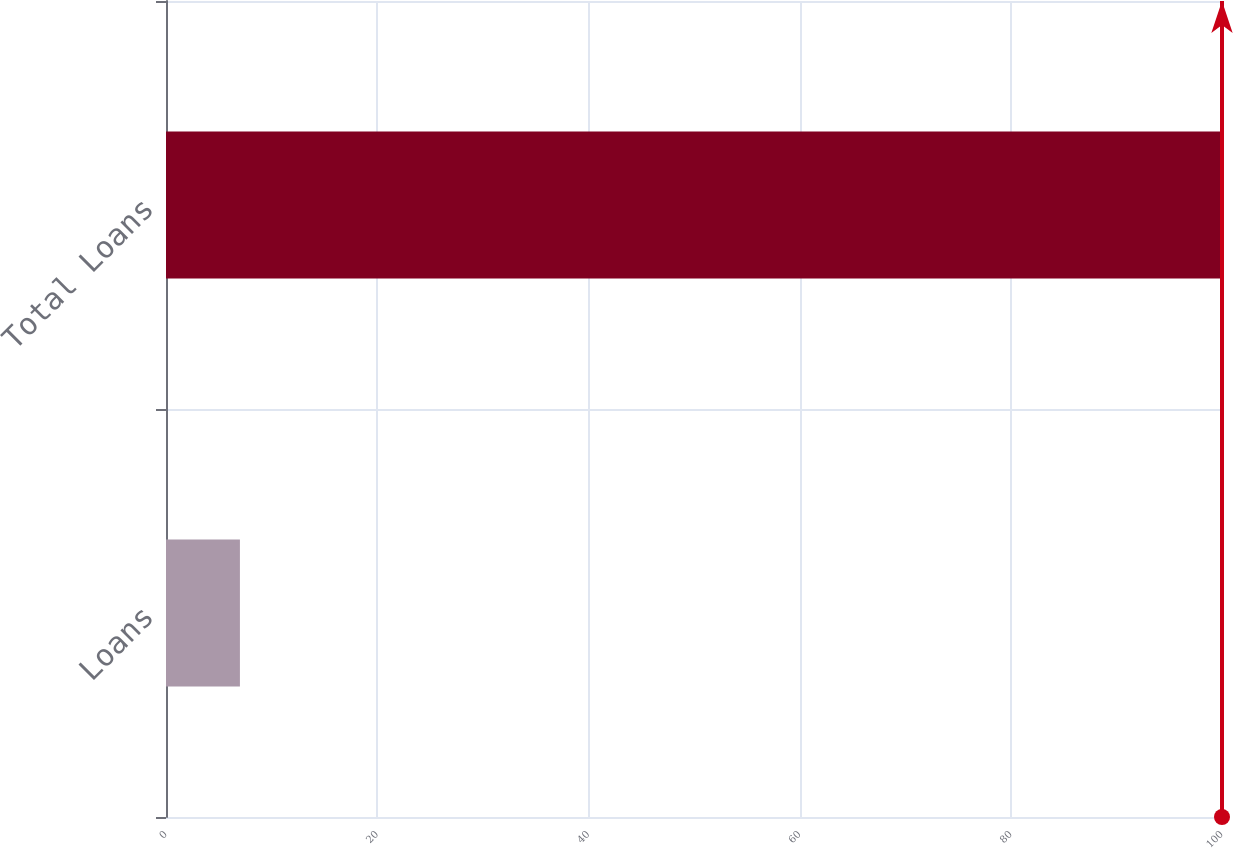<chart> <loc_0><loc_0><loc_500><loc_500><bar_chart><fcel>Loans<fcel>Total Loans<nl><fcel>7<fcel>100<nl></chart> 